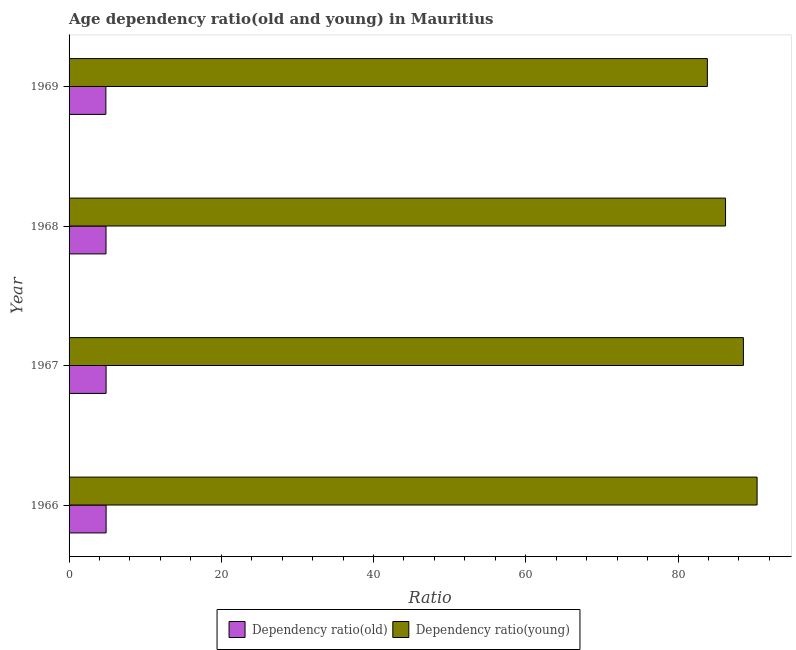Are the number of bars per tick equal to the number of legend labels?
Offer a terse response. Yes. Are the number of bars on each tick of the Y-axis equal?
Ensure brevity in your answer.  Yes. How many bars are there on the 3rd tick from the bottom?
Your response must be concise. 2. What is the label of the 4th group of bars from the top?
Your answer should be compact. 1966. In how many cases, is the number of bars for a given year not equal to the number of legend labels?
Offer a very short reply. 0. What is the age dependency ratio(young) in 1966?
Give a very brief answer. 90.39. Across all years, what is the maximum age dependency ratio(old)?
Provide a succinct answer. 4.87. Across all years, what is the minimum age dependency ratio(young)?
Your answer should be compact. 83.86. In which year was the age dependency ratio(young) maximum?
Make the answer very short. 1966. In which year was the age dependency ratio(young) minimum?
Your answer should be very brief. 1969. What is the total age dependency ratio(young) in the graph?
Offer a terse response. 349.09. What is the difference between the age dependency ratio(young) in 1967 and that in 1969?
Offer a very short reply. 4.73. What is the difference between the age dependency ratio(young) in 1966 and the age dependency ratio(old) in 1968?
Make the answer very short. 85.54. What is the average age dependency ratio(young) per year?
Keep it short and to the point. 87.27. In the year 1966, what is the difference between the age dependency ratio(old) and age dependency ratio(young)?
Give a very brief answer. -85.53. In how many years, is the age dependency ratio(old) greater than 28 ?
Offer a very short reply. 0. What is the ratio of the age dependency ratio(young) in 1966 to that in 1969?
Ensure brevity in your answer.  1.08. Is the difference between the age dependency ratio(old) in 1966 and 1967 greater than the difference between the age dependency ratio(young) in 1966 and 1967?
Keep it short and to the point. No. What is the difference between the highest and the second highest age dependency ratio(old)?
Ensure brevity in your answer.  0. What is the difference between the highest and the lowest age dependency ratio(old)?
Your answer should be compact. 0.03. Is the sum of the age dependency ratio(old) in 1968 and 1969 greater than the maximum age dependency ratio(young) across all years?
Offer a terse response. No. What does the 2nd bar from the top in 1969 represents?
Provide a succinct answer. Dependency ratio(old). What does the 1st bar from the bottom in 1969 represents?
Offer a very short reply. Dependency ratio(old). Are all the bars in the graph horizontal?
Ensure brevity in your answer.  Yes. How many years are there in the graph?
Ensure brevity in your answer.  4. Does the graph contain any zero values?
Offer a very short reply. No. Does the graph contain grids?
Your response must be concise. No. Where does the legend appear in the graph?
Offer a terse response. Bottom center. How many legend labels are there?
Your response must be concise. 2. How are the legend labels stacked?
Provide a succinct answer. Horizontal. What is the title of the graph?
Give a very brief answer. Age dependency ratio(old and young) in Mauritius. What is the label or title of the X-axis?
Make the answer very short. Ratio. What is the Ratio in Dependency ratio(old) in 1966?
Offer a very short reply. 4.87. What is the Ratio of Dependency ratio(young) in 1966?
Keep it short and to the point. 90.39. What is the Ratio of Dependency ratio(old) in 1967?
Your response must be concise. 4.86. What is the Ratio in Dependency ratio(young) in 1967?
Ensure brevity in your answer.  88.59. What is the Ratio in Dependency ratio(old) in 1968?
Provide a succinct answer. 4.85. What is the Ratio in Dependency ratio(young) in 1968?
Offer a terse response. 86.24. What is the Ratio in Dependency ratio(old) in 1969?
Offer a terse response. 4.83. What is the Ratio of Dependency ratio(young) in 1969?
Your answer should be very brief. 83.86. Across all years, what is the maximum Ratio in Dependency ratio(old)?
Your response must be concise. 4.87. Across all years, what is the maximum Ratio of Dependency ratio(young)?
Keep it short and to the point. 90.39. Across all years, what is the minimum Ratio of Dependency ratio(old)?
Offer a very short reply. 4.83. Across all years, what is the minimum Ratio of Dependency ratio(young)?
Provide a succinct answer. 83.86. What is the total Ratio of Dependency ratio(old) in the graph?
Your answer should be very brief. 19.42. What is the total Ratio of Dependency ratio(young) in the graph?
Your answer should be very brief. 349.09. What is the difference between the Ratio in Dependency ratio(old) in 1966 and that in 1967?
Keep it short and to the point. 0. What is the difference between the Ratio of Dependency ratio(young) in 1966 and that in 1967?
Provide a short and direct response. 1.8. What is the difference between the Ratio in Dependency ratio(old) in 1966 and that in 1968?
Give a very brief answer. 0.01. What is the difference between the Ratio in Dependency ratio(young) in 1966 and that in 1968?
Provide a short and direct response. 4.15. What is the difference between the Ratio in Dependency ratio(old) in 1966 and that in 1969?
Your answer should be very brief. 0.03. What is the difference between the Ratio in Dependency ratio(young) in 1966 and that in 1969?
Make the answer very short. 6.53. What is the difference between the Ratio of Dependency ratio(old) in 1967 and that in 1968?
Keep it short and to the point. 0.01. What is the difference between the Ratio in Dependency ratio(young) in 1967 and that in 1968?
Offer a very short reply. 2.35. What is the difference between the Ratio in Dependency ratio(old) in 1967 and that in 1969?
Make the answer very short. 0.03. What is the difference between the Ratio in Dependency ratio(young) in 1967 and that in 1969?
Keep it short and to the point. 4.73. What is the difference between the Ratio in Dependency ratio(old) in 1968 and that in 1969?
Give a very brief answer. 0.02. What is the difference between the Ratio in Dependency ratio(young) in 1968 and that in 1969?
Give a very brief answer. 2.38. What is the difference between the Ratio in Dependency ratio(old) in 1966 and the Ratio in Dependency ratio(young) in 1967?
Keep it short and to the point. -83.73. What is the difference between the Ratio in Dependency ratio(old) in 1966 and the Ratio in Dependency ratio(young) in 1968?
Your answer should be very brief. -81.38. What is the difference between the Ratio in Dependency ratio(old) in 1966 and the Ratio in Dependency ratio(young) in 1969?
Give a very brief answer. -78.99. What is the difference between the Ratio in Dependency ratio(old) in 1967 and the Ratio in Dependency ratio(young) in 1968?
Make the answer very short. -81.38. What is the difference between the Ratio of Dependency ratio(old) in 1967 and the Ratio of Dependency ratio(young) in 1969?
Ensure brevity in your answer.  -79. What is the difference between the Ratio in Dependency ratio(old) in 1968 and the Ratio in Dependency ratio(young) in 1969?
Offer a very short reply. -79.01. What is the average Ratio of Dependency ratio(old) per year?
Provide a short and direct response. 4.85. What is the average Ratio in Dependency ratio(young) per year?
Provide a short and direct response. 87.27. In the year 1966, what is the difference between the Ratio in Dependency ratio(old) and Ratio in Dependency ratio(young)?
Your answer should be compact. -85.53. In the year 1967, what is the difference between the Ratio of Dependency ratio(old) and Ratio of Dependency ratio(young)?
Offer a terse response. -83.73. In the year 1968, what is the difference between the Ratio of Dependency ratio(old) and Ratio of Dependency ratio(young)?
Provide a short and direct response. -81.39. In the year 1969, what is the difference between the Ratio of Dependency ratio(old) and Ratio of Dependency ratio(young)?
Provide a short and direct response. -79.03. What is the ratio of the Ratio of Dependency ratio(young) in 1966 to that in 1967?
Offer a very short reply. 1.02. What is the ratio of the Ratio of Dependency ratio(old) in 1966 to that in 1968?
Make the answer very short. 1. What is the ratio of the Ratio of Dependency ratio(young) in 1966 to that in 1968?
Your answer should be very brief. 1.05. What is the ratio of the Ratio of Dependency ratio(old) in 1966 to that in 1969?
Give a very brief answer. 1.01. What is the ratio of the Ratio of Dependency ratio(young) in 1966 to that in 1969?
Keep it short and to the point. 1.08. What is the ratio of the Ratio of Dependency ratio(young) in 1967 to that in 1968?
Your response must be concise. 1.03. What is the ratio of the Ratio in Dependency ratio(old) in 1967 to that in 1969?
Offer a very short reply. 1.01. What is the ratio of the Ratio of Dependency ratio(young) in 1967 to that in 1969?
Make the answer very short. 1.06. What is the ratio of the Ratio in Dependency ratio(old) in 1968 to that in 1969?
Make the answer very short. 1. What is the ratio of the Ratio in Dependency ratio(young) in 1968 to that in 1969?
Provide a succinct answer. 1.03. What is the difference between the highest and the second highest Ratio in Dependency ratio(old)?
Your answer should be very brief. 0. What is the difference between the highest and the second highest Ratio of Dependency ratio(young)?
Give a very brief answer. 1.8. What is the difference between the highest and the lowest Ratio in Dependency ratio(old)?
Offer a very short reply. 0.03. What is the difference between the highest and the lowest Ratio of Dependency ratio(young)?
Make the answer very short. 6.53. 